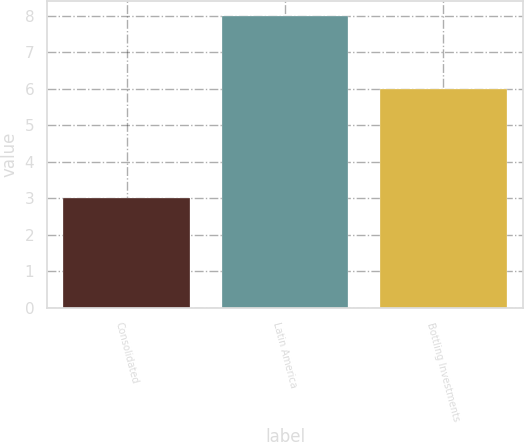Convert chart. <chart><loc_0><loc_0><loc_500><loc_500><bar_chart><fcel>Consolidated<fcel>Latin America<fcel>Bottling Investments<nl><fcel>3<fcel>8<fcel>6<nl></chart> 